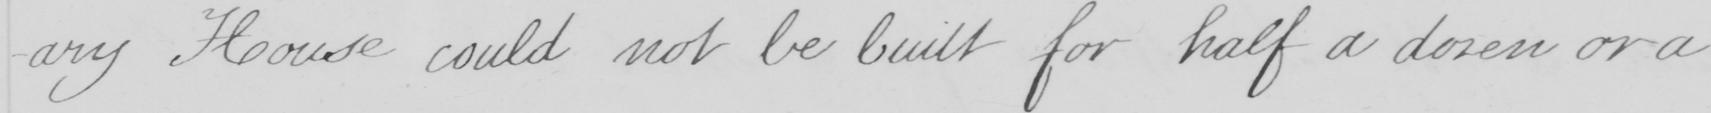Please provide the text content of this handwritten line. -iary House could not be built for half a dozen or a 